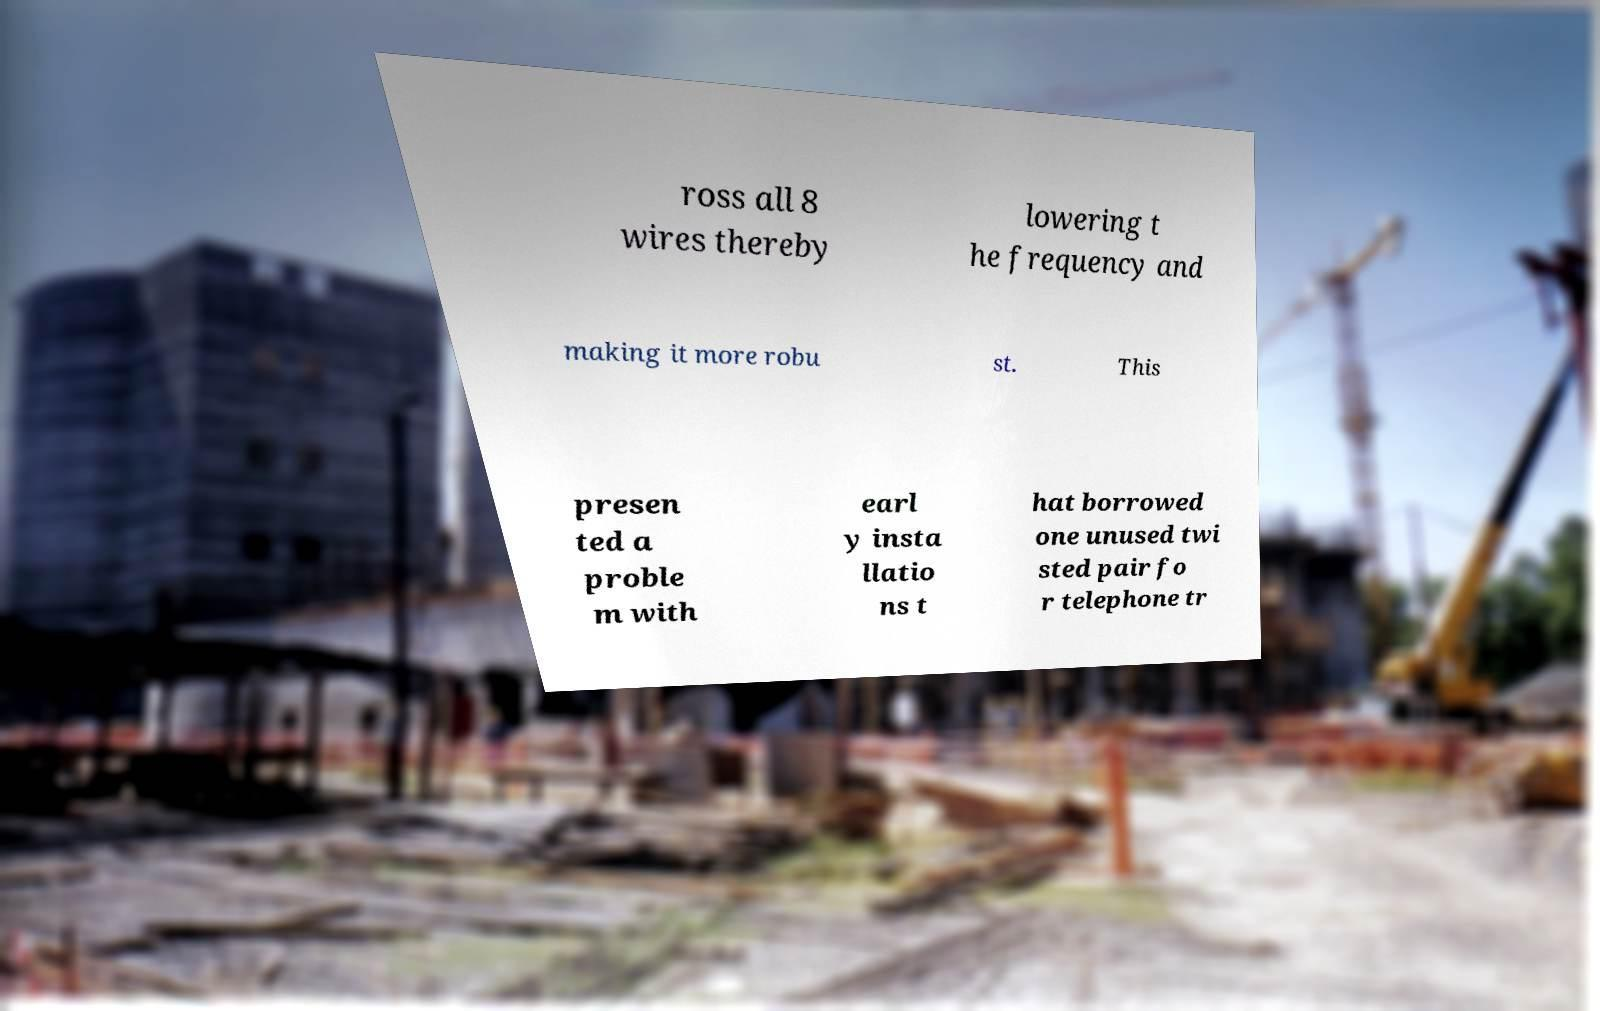Please identify and transcribe the text found in this image. ross all 8 wires thereby lowering t he frequency and making it more robu st. This presen ted a proble m with earl y insta llatio ns t hat borrowed one unused twi sted pair fo r telephone tr 